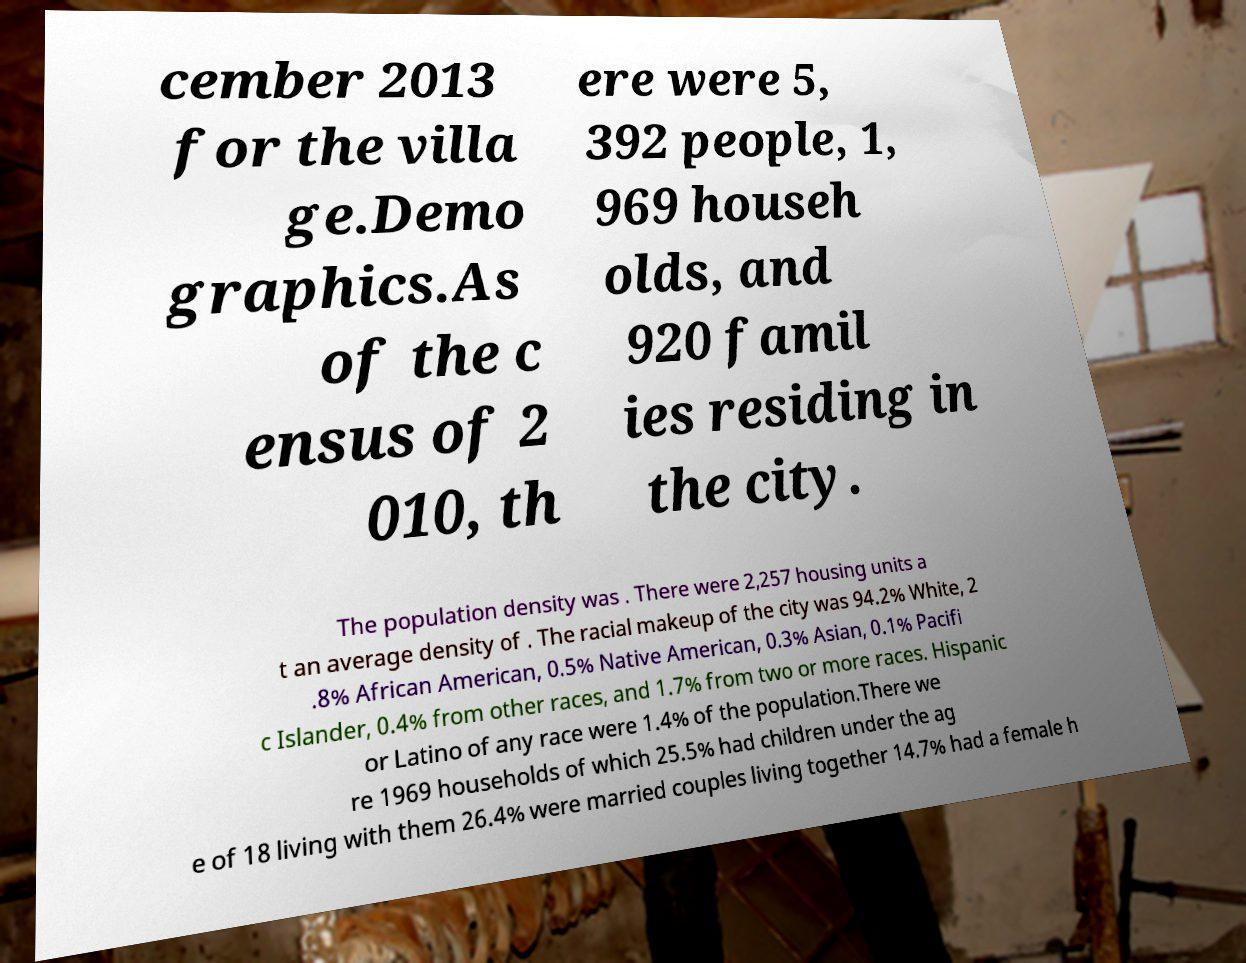I need the written content from this picture converted into text. Can you do that? cember 2013 for the villa ge.Demo graphics.As of the c ensus of 2 010, th ere were 5, 392 people, 1, 969 househ olds, and 920 famil ies residing in the city. The population density was . There were 2,257 housing units a t an average density of . The racial makeup of the city was 94.2% White, 2 .8% African American, 0.5% Native American, 0.3% Asian, 0.1% Pacifi c Islander, 0.4% from other races, and 1.7% from two or more races. Hispanic or Latino of any race were 1.4% of the population.There we re 1969 households of which 25.5% had children under the ag e of 18 living with them 26.4% were married couples living together 14.7% had a female h 